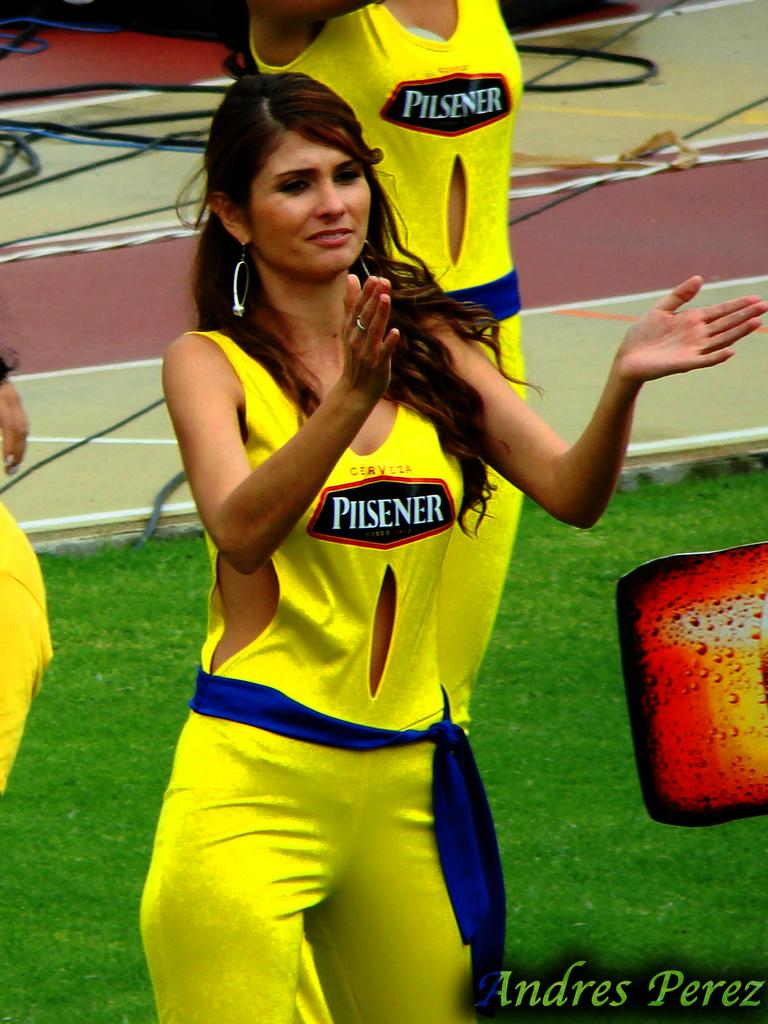<image>
Offer a succinct explanation of the picture presented. A woman in a yellow shirt that says Pilsener is standing on a field. 